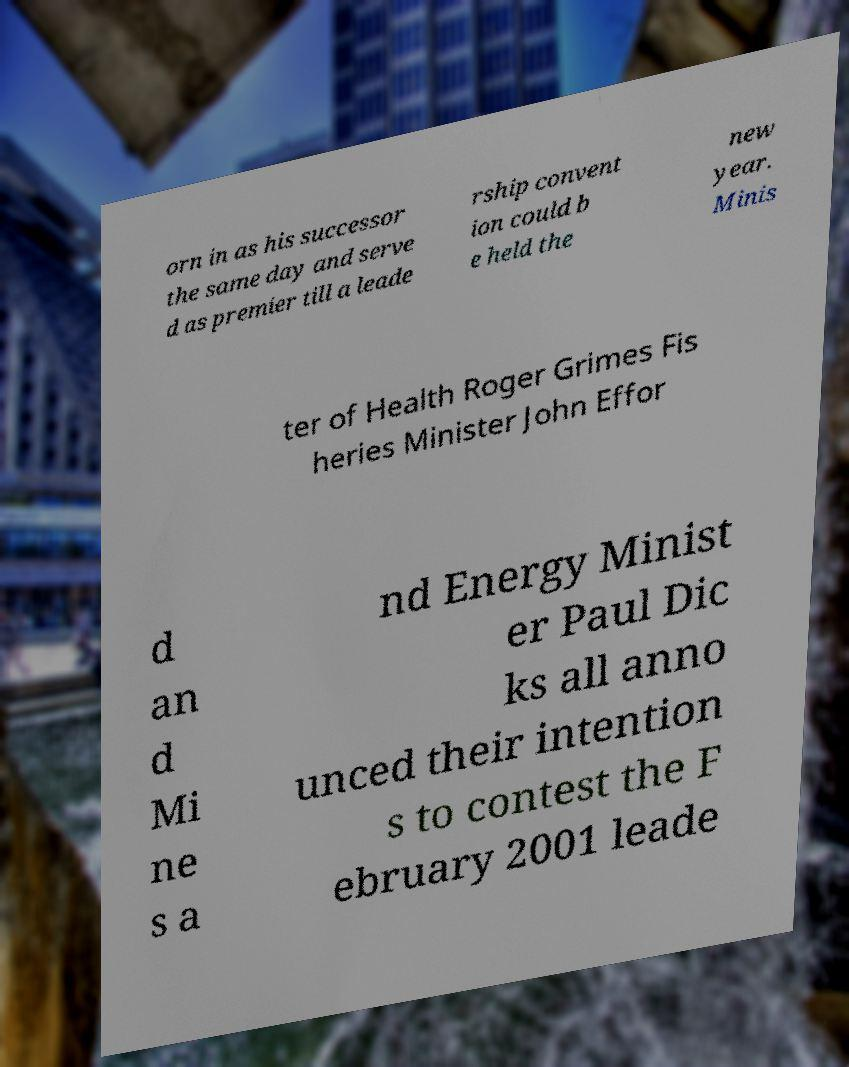Can you read and provide the text displayed in the image?This photo seems to have some interesting text. Can you extract and type it out for me? orn in as his successor the same day and serve d as premier till a leade rship convent ion could b e held the new year. Minis ter of Health Roger Grimes Fis heries Minister John Effor d an d Mi ne s a nd Energy Minist er Paul Dic ks all anno unced their intention s to contest the F ebruary 2001 leade 